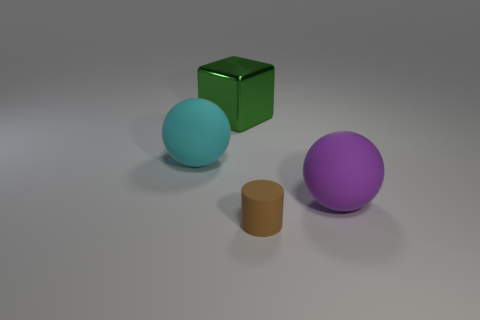Is there any other thing that has the same size as the brown cylinder?
Your answer should be very brief. No. There is a big green metal object that is on the left side of the big purple sphere; is its shape the same as the matte object that is left of the brown object?
Provide a succinct answer. No. Is there anything else that has the same material as the tiny object?
Your answer should be very brief. Yes. What is the tiny object made of?
Ensure brevity in your answer.  Rubber. There is a ball in front of the cyan rubber ball; what material is it?
Provide a succinct answer. Rubber. Is there anything else of the same color as the tiny rubber object?
Your answer should be compact. No. The other ball that is the same material as the big purple ball is what size?
Your response must be concise. Large. How many large things are red metal blocks or metal blocks?
Offer a terse response. 1. There is a matte thing that is in front of the matte sphere to the right of the matte thing that is in front of the purple rubber thing; what is its size?
Keep it short and to the point. Small. How many purple rubber objects are the same size as the brown rubber object?
Make the answer very short. 0. 